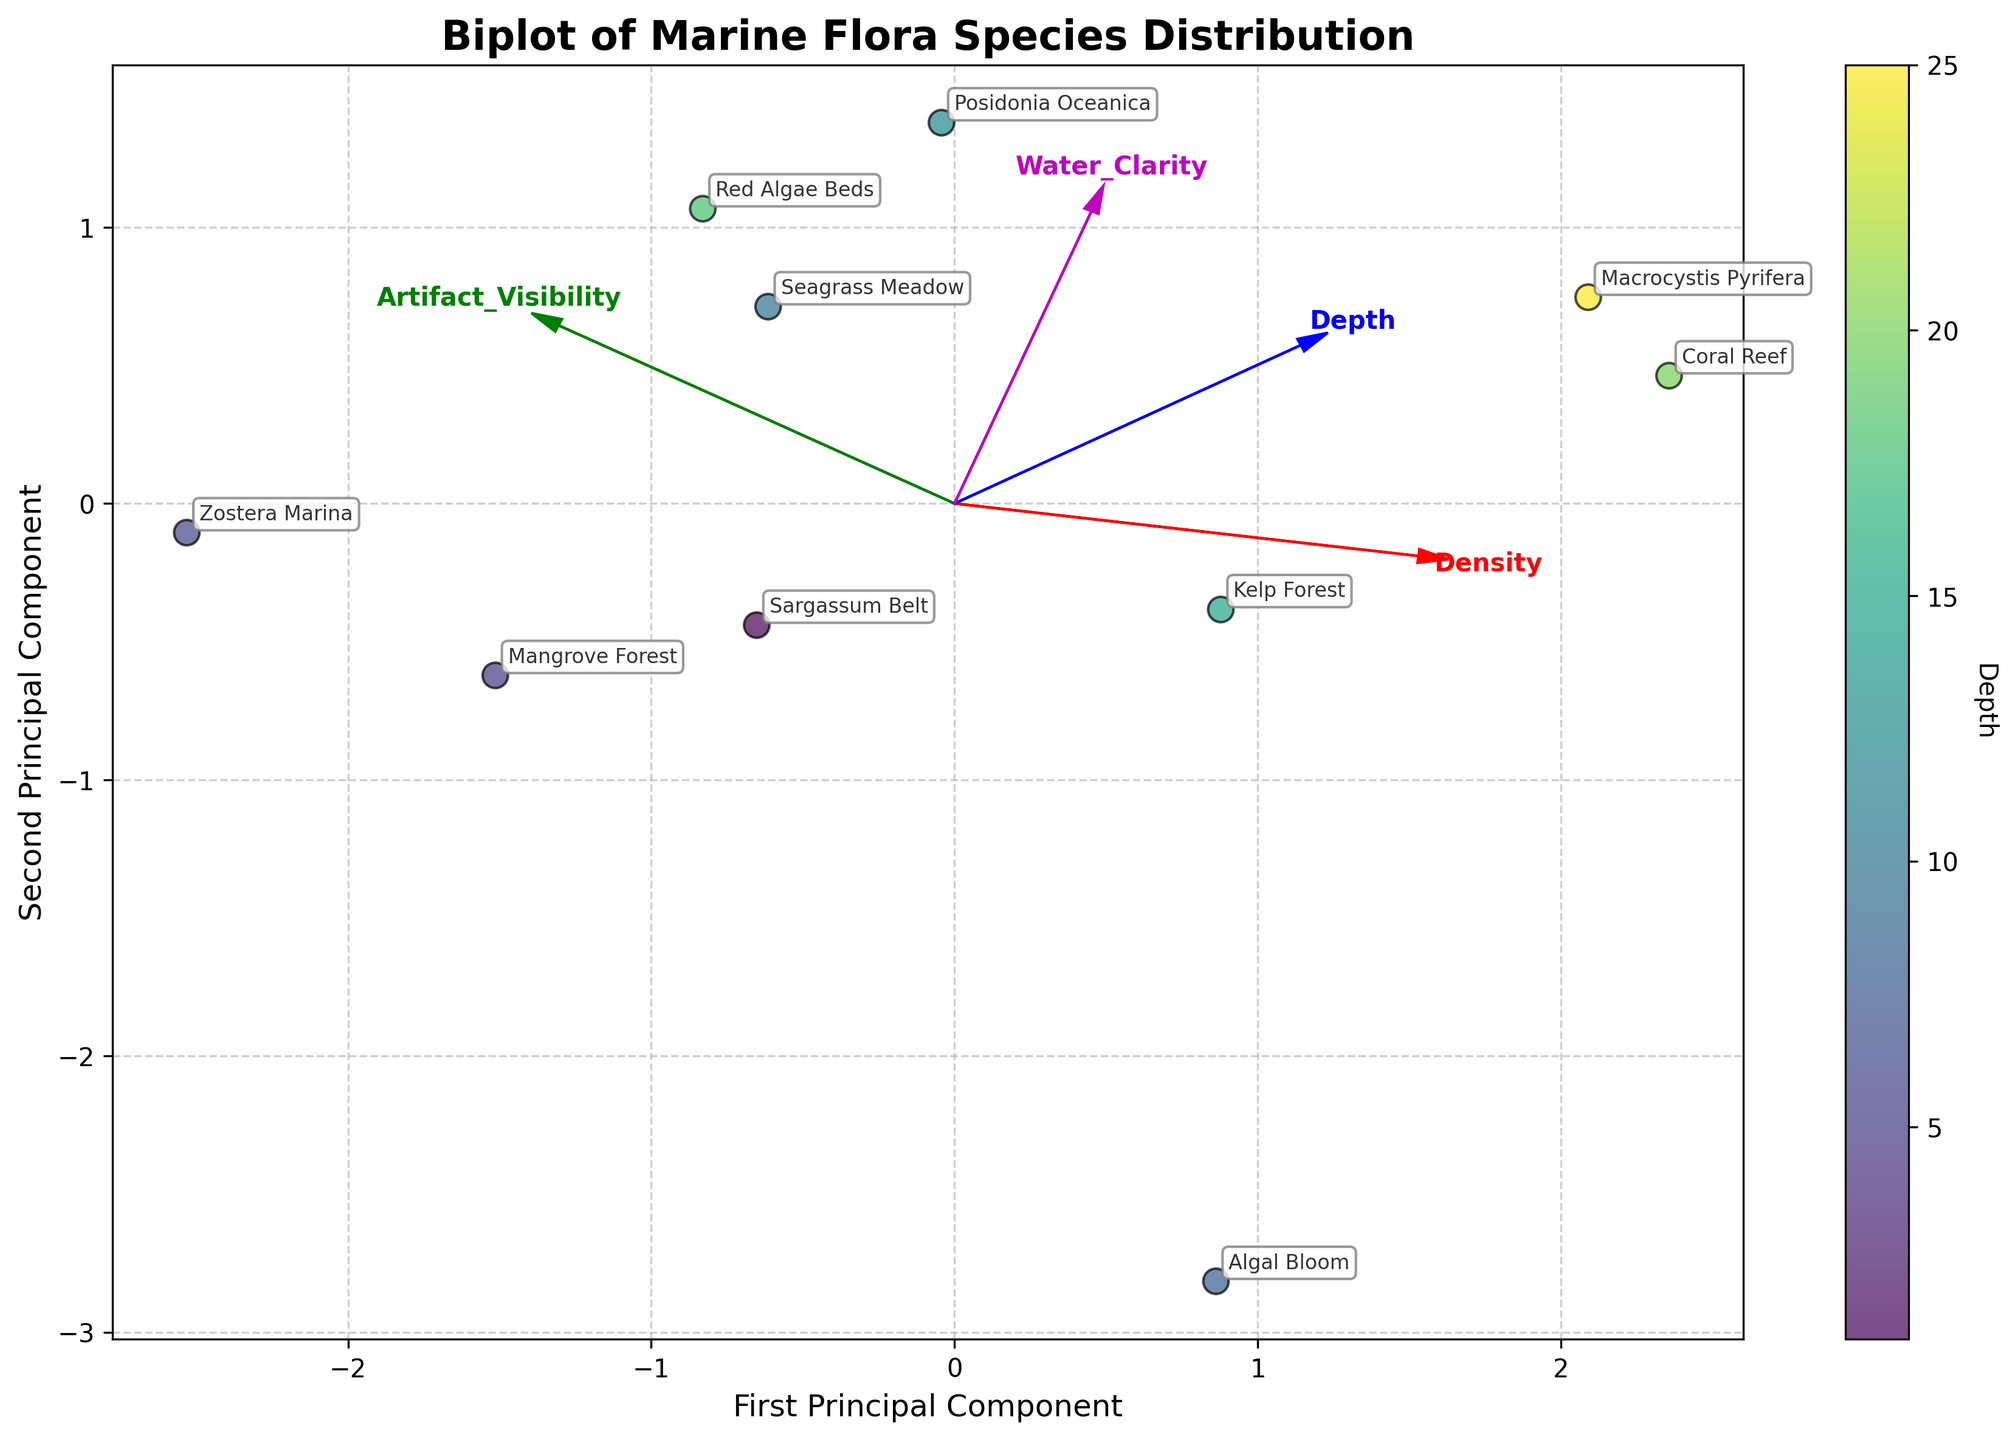What is the title of the biplot? The title of a biplot is usually prominently displayed at the top of the figure to provide an immediate understanding of what the visualization represents. In this case, the title is "Biplot of Marine Flora Species Distribution".
Answer: Biplot of Marine Flora Species Distribution How many data points are plotted in the biplot? To determine the number of data points, count each distinct point on the plot. Each data point represents a different marine flora species. By counting the points, you will find 10 in total.
Answer: 10 What is the label of the x-axis? The x-axis label is usually found at the bottom of the horizontal axis. In this figure, it is "First Principal Component".
Answer: First Principal Component Which marine flora species has the highest artifact visibility? Look at the annotations placed near the points on the biplot and find the one with the highest value for artifact visibility. Based on this, "Zostera Marina" has the highest artifact visibility.
Answer: Zostera Marina Which feature vector points in the same general direction as the 'Artifact Visibility' vector? By examining the arrows representing the feature vectors, identify which other vectors are pointing in a similar direction to the 'Artifact Visibility' vector. The 'Water Clarity' vector is more or less aligned in the same direction.
Answer: Water Clarity How is depth encoded in the biplot? Depth is displayed by the color of the data points, with a colorbar indicating the scale. The color ranges from light to dark, corresponding to the depth value.
Answer: By the color of the data points Which region's marine flora species are closest to the origin in the biplot? Examine the plot and locate the data point that is closest to the (0,0) origin. The species from the "Mangrove Forest" (Florida Keys) is nearest to the origin.
Answer: Florida Keys Between 'Kelp Forest' and 'Macrocystis Pyrifera', which has a higher density? Compare the annotation for 'Kelp Forest' (California Coast) and 'Macrocystis Pyrifera' (Chilean Coast). The density values represented by these two points show that 'Macrocystis Pyrifera' has a higher density.
Answer: Macrocystis Pyrifera Which feature contributes most to the first principal component? Assess the length and direction of the feature vectors in relation to the first principal component (x-axis). The 'Density' vector is longest and align mostly horizontally, indicating it contributes the most.
Answer: Density 